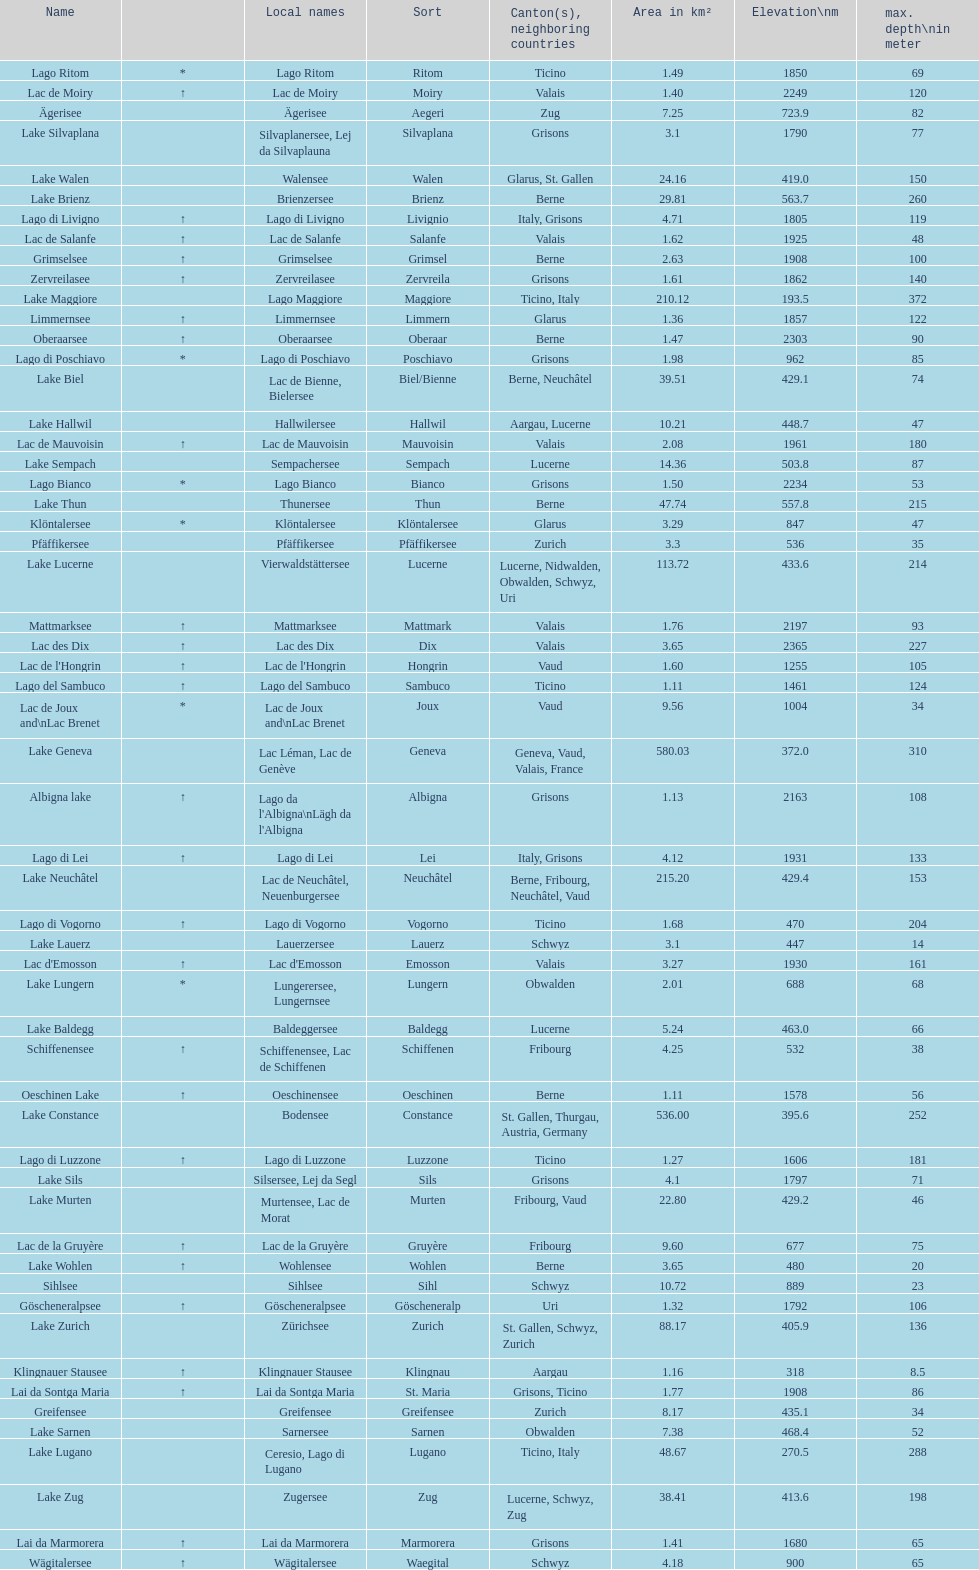What is the number of lakes that have an area less than 100 km squared? 51. 